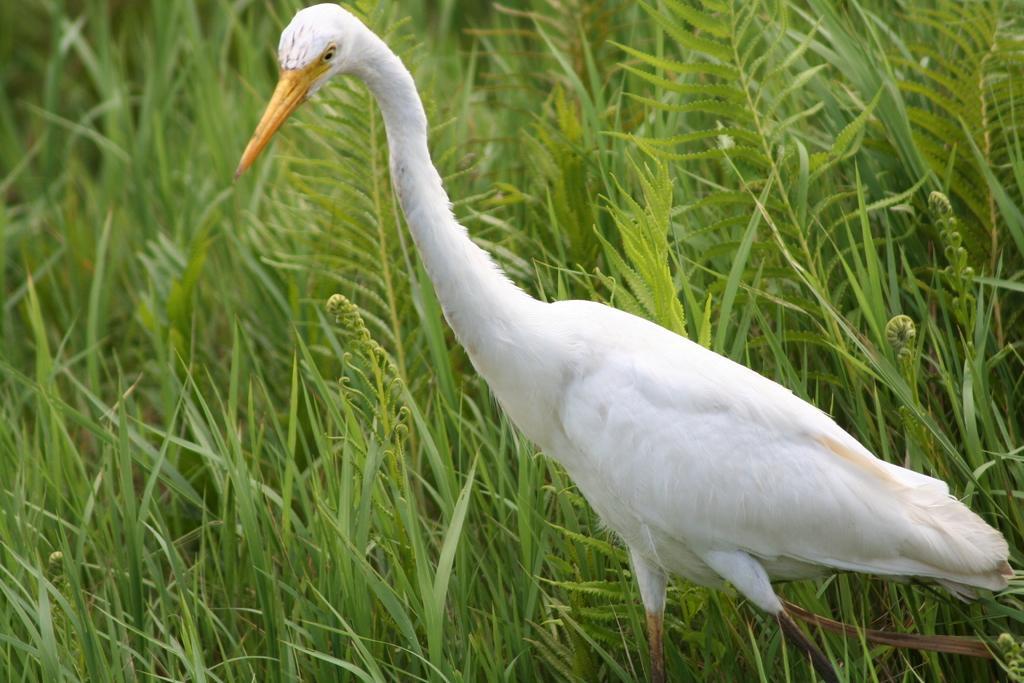Describe this image in one or two sentences. There is a white crane with yellow beak is in the grasses. 